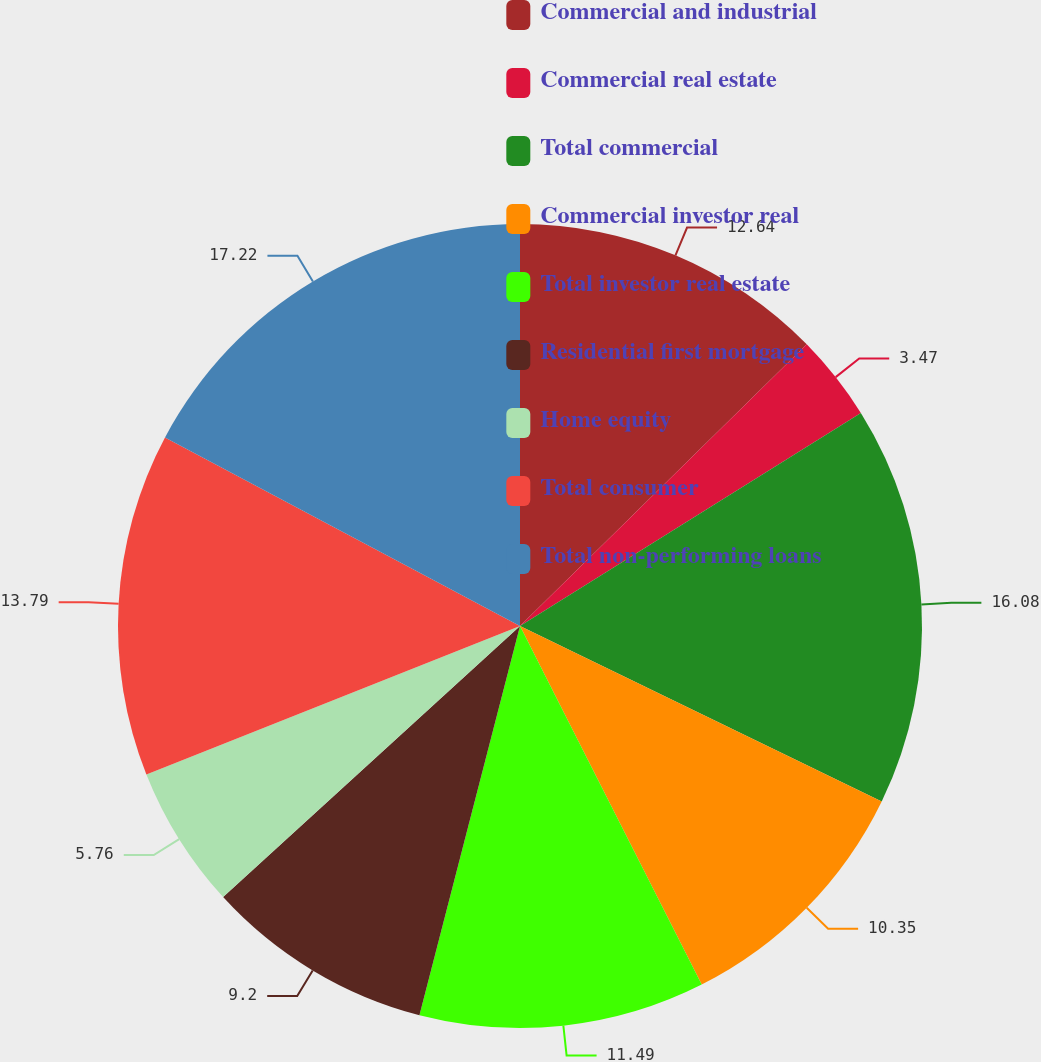Convert chart. <chart><loc_0><loc_0><loc_500><loc_500><pie_chart><fcel>Commercial and industrial<fcel>Commercial real estate<fcel>Total commercial<fcel>Commercial investor real<fcel>Total investor real estate<fcel>Residential first mortgage<fcel>Home equity<fcel>Total consumer<fcel>Total non-performing loans<nl><fcel>12.64%<fcel>3.47%<fcel>16.08%<fcel>10.35%<fcel>11.49%<fcel>9.2%<fcel>5.76%<fcel>13.79%<fcel>17.23%<nl></chart> 